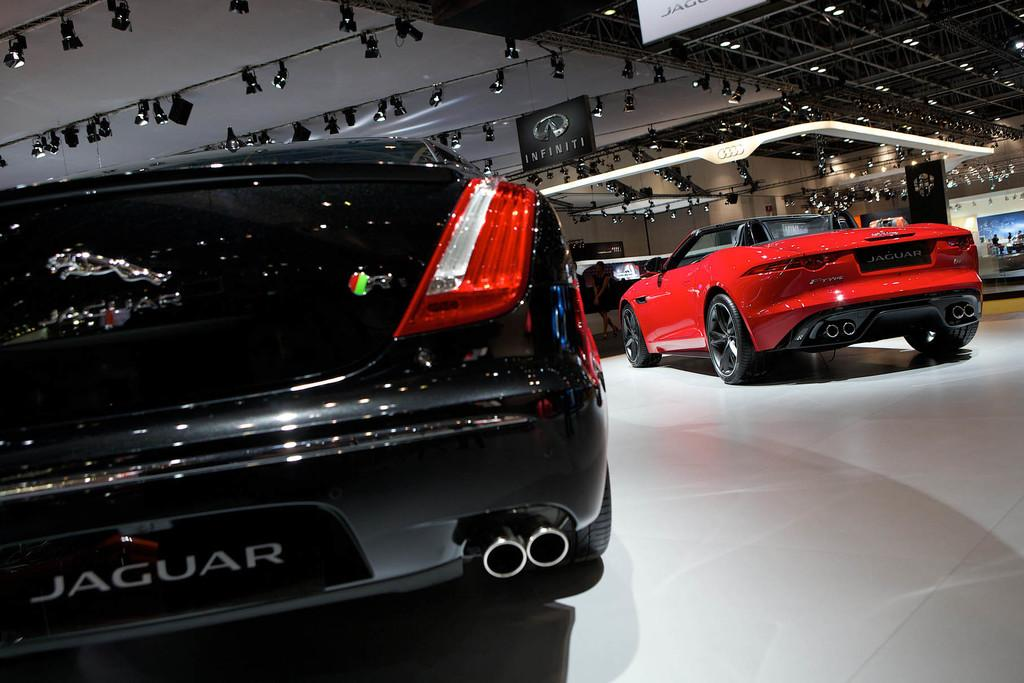What type of objects can be seen on the floor in the image? There are motor vehicles placed on the floor in the image. What other features are present in the image besides the motor vehicles? There are electric lights and information boards in the image. Can you describe the woman in the image? There is a woman in the image, but no specific details about her appearance or actions are provided. What type of mist can be seen surrounding the motor vehicles in the image? There is no mist present in the image; the motor vehicles are clearly visible on the floor. 